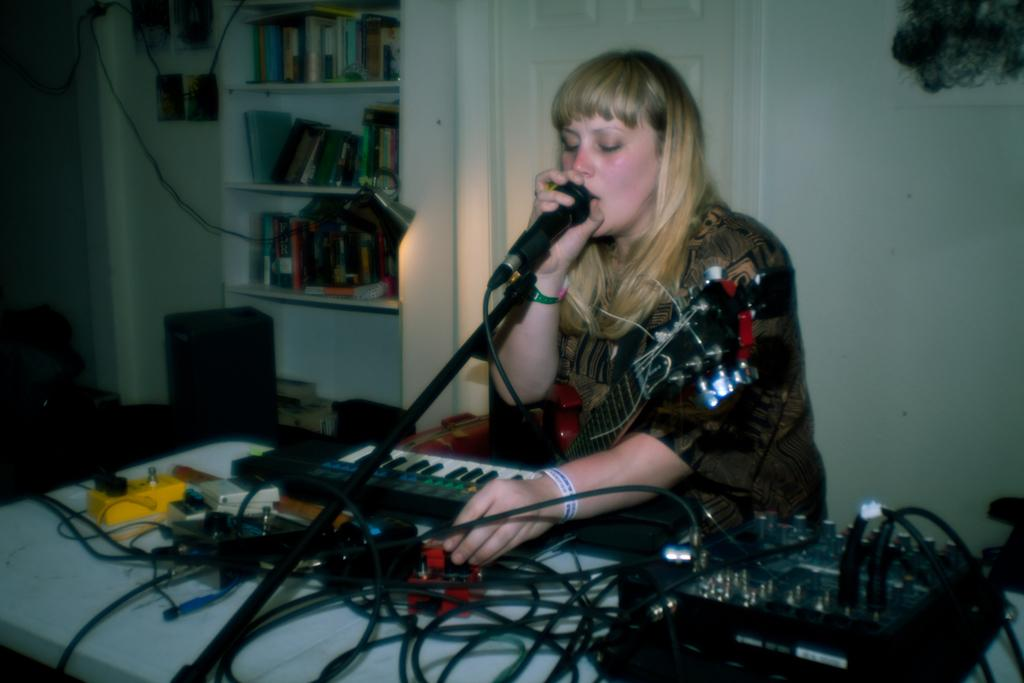What is the main subject of the image? There is a person in the image. What else can be seen in the image besides the person? There are musical instruments and other objects in the image. Can you describe the background of the image? There is a wall, a door, books, and other objects in the background of the image. How many cakes are on the sand in the image? There is no sand or cakes present in the image. 